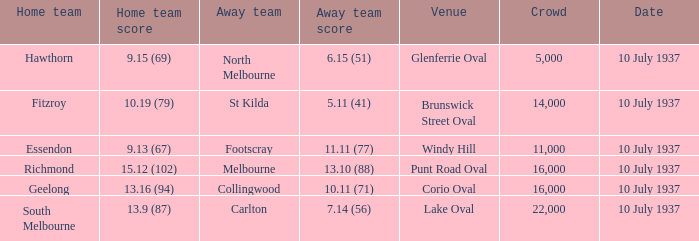Help me parse the entirety of this table. {'header': ['Home team', 'Home team score', 'Away team', 'Away team score', 'Venue', 'Crowd', 'Date'], 'rows': [['Hawthorn', '9.15 (69)', 'North Melbourne', '6.15 (51)', 'Glenferrie Oval', '5,000', '10 July 1937'], ['Fitzroy', '10.19 (79)', 'St Kilda', '5.11 (41)', 'Brunswick Street Oval', '14,000', '10 July 1937'], ['Essendon', '9.13 (67)', 'Footscray', '11.11 (77)', 'Windy Hill', '11,000', '10 July 1937'], ['Richmond', '15.12 (102)', 'Melbourne', '13.10 (88)', 'Punt Road Oval', '16,000', '10 July 1937'], ['Geelong', '13.16 (94)', 'Collingwood', '10.11 (71)', 'Corio Oval', '16,000', '10 July 1937'], ['South Melbourne', '13.9 (87)', 'Carlton', '7.14 (56)', 'Lake Oval', '22,000', '10 July 1937']]} What was the site of the north melbourne away team? Glenferrie Oval. 